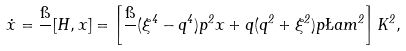Convert formula to latex. <formula><loc_0><loc_0><loc_500><loc_500>\dot { x } = \frac { \i } { } [ H , x ] = \left [ \frac { \i } { } ( \xi ^ { 4 } - q ^ { 4 } ) p ^ { 2 } x + q ( q ^ { 2 } + \xi ^ { 2 } ) p \L a m ^ { 2 } \right ] K ^ { 2 } ,</formula> 